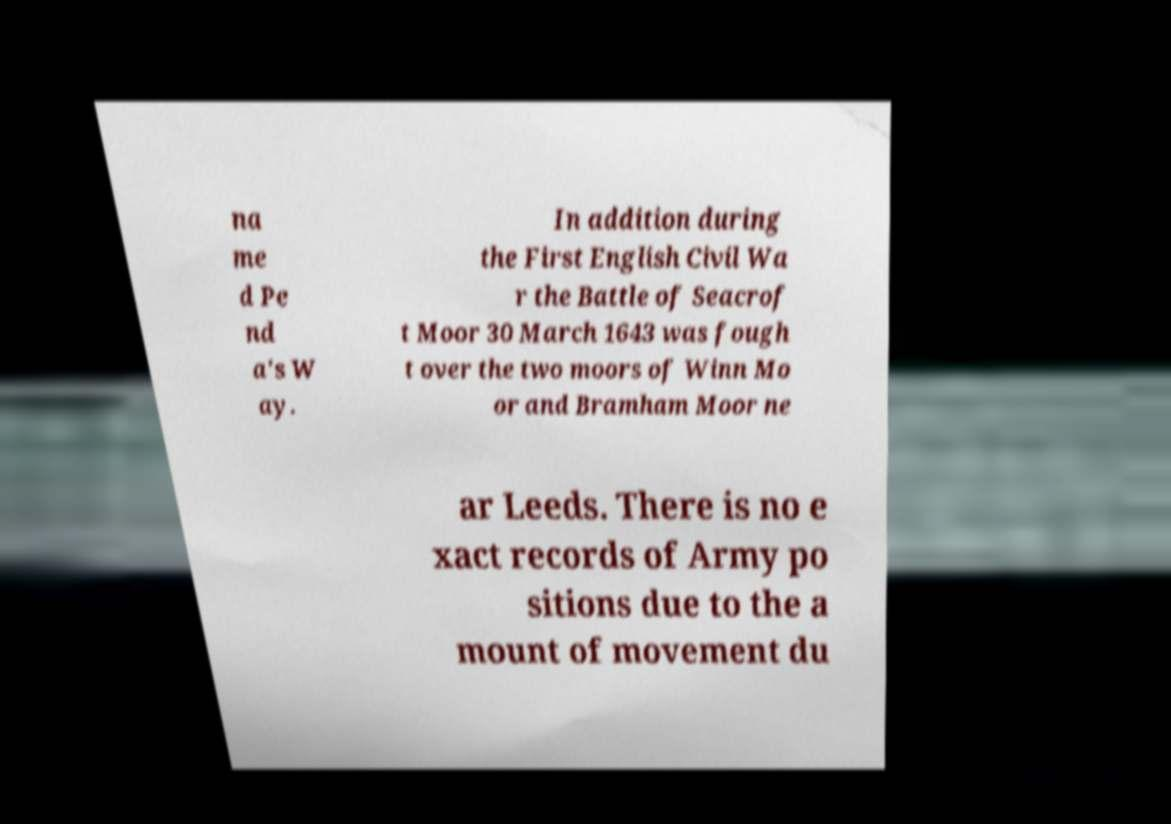There's text embedded in this image that I need extracted. Can you transcribe it verbatim? na me d Pe nd a's W ay. In addition during the First English Civil Wa r the Battle of Seacrof t Moor 30 March 1643 was fough t over the two moors of Winn Mo or and Bramham Moor ne ar Leeds. There is no e xact records of Army po sitions due to the a mount of movement du 